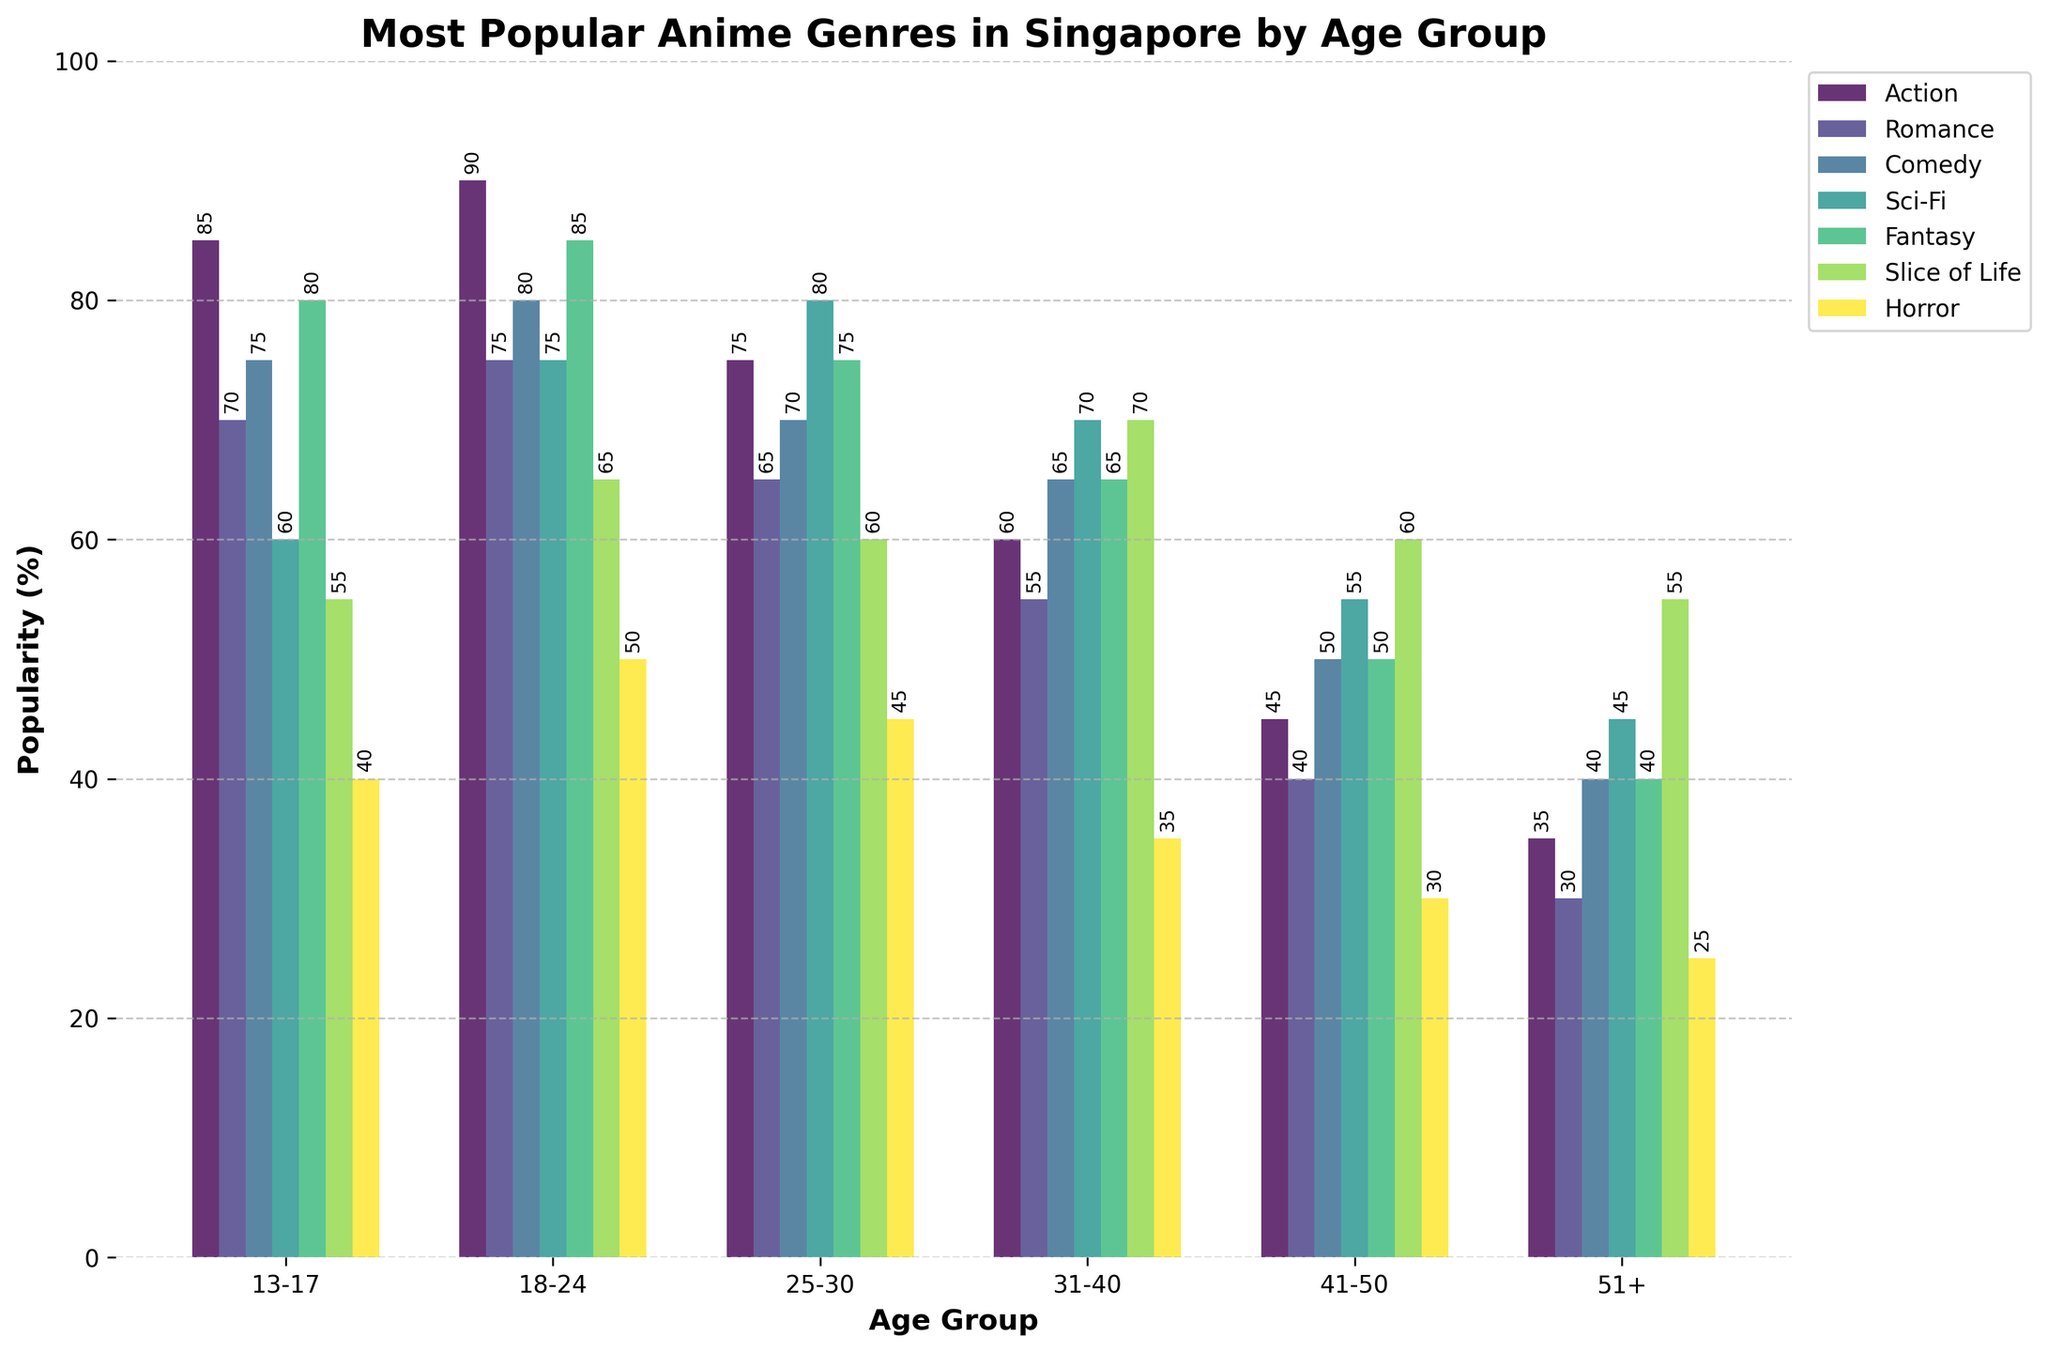Which anime genre is the most popular among the age group 18-24? Look at the bar heights in the '18-24' age group and identify which is tallest.
Answer: Action Which age group shows the highest interest in the Slice of Life genre? Compare the bar heights representing the Slice of Life genre across all age groups.
Answer: 18-24 How does the popularity of the Horror genre among the 13-17 age group compare to the 51+ age group? Check the bar heights for Horror in the '13-17' and '51+' age groups and compare them.
Answer: Higher in 13-17 On average, how does the interest in Sci-Fi change as the age groups progress from 13-17 to 51+? Calculate the mean of the Sci-Fi percentages: (60 + 75 + 80 + 70 + 55 + 45) / 6.
Answer: 64.2% Which three genres are most popular among the age group 25-30? Identify the three tallest bars in the '25-30' age group.
Answer: Sci-Fi, Fantasy, Action Among the 31-40 age group, which genre has the second highest popularity after Sci-Fi? Find the highest bar in the '31-40' age group first (Sci-Fi), then find the next highest.
Answer: Slice of Life What is the difference in the popularity of Action and Romance genres among the 51+ age group? Subtract the Romance percentage from the Action percentage for the '51+' age group.
Answer: 5 Which genre shows a consistent decrease in popularity as age increases? Analyze the trend for each genre across the age groups to see which one consistently decreases.
Answer: Action How does the popularity of Fantasy change from the 13-17 age group to the 41-50 age group? Compare the Fantasy percentages in '13-17' (80) and '41-50' (50).
Answer: Decreases by 30 What is the sum of popularity percentages for the Comedy genre across all age groups? Add the percentages in Comedy for all age groups: 75 + 80 + 70 + 65 + 50 + 40.
Answer: 380 